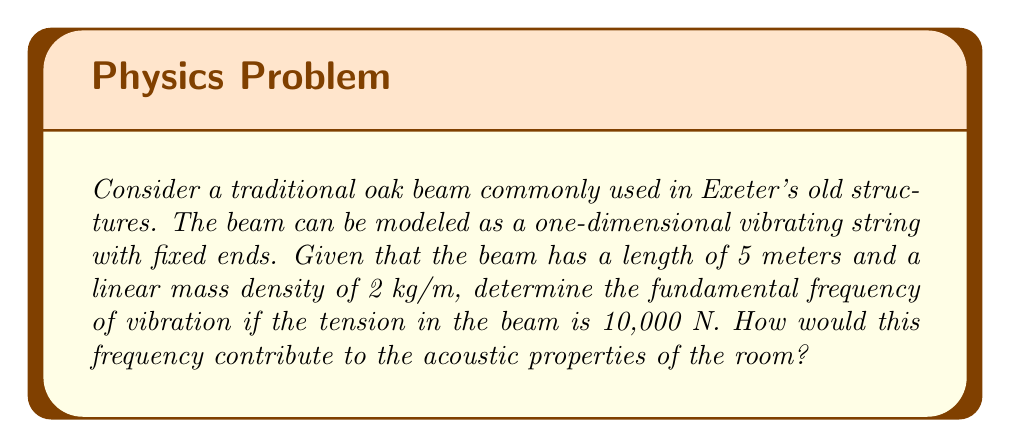What is the answer to this math problem? To solve this problem, we'll use the wave equation and spectral theory to determine the fundamental frequency of the oak beam.

1. The wave equation for a vibrating string is given by:

   $$\frac{\partial^2 u}{\partial t^2} = c^2 \frac{\partial^2 u}{\partial x^2}$$

   where $c$ is the wave speed.

2. The wave speed $c$ is related to the tension $T$ and linear mass density $\mu$ by:

   $$c = \sqrt{\frac{T}{\mu}}$$

3. Substituting the given values:
   $T = 10,000$ N
   $\mu = 2$ kg/m

   $$c = \sqrt{\frac{10,000}{2}} = \sqrt{5,000} \approx 70.71 \text{ m/s}$$

4. For a string with fixed ends, the eigenvalue problem is:

   $$-\frac{d^2\phi}{dx^2} = \lambda \phi$$
   
   with boundary conditions $\phi(0) = \phi(L) = 0$, where $L$ is the length of the string.

5. The eigenvalues are given by:

   $$\lambda_n = \left(\frac{n\pi}{L}\right)^2$$

   where $n = 1, 2, 3, ...$

6. The corresponding eigenfrequencies are:

   $$f_n = \frac{c}{2L} n$$

7. The fundamental frequency is the first eigenfrequency ($n = 1$):

   $$f_1 = \frac{c}{2L} = \frac{70.71}{2 \cdot 5} \approx 7.07 \text{ Hz}$$

8. This low-frequency vibration would contribute to the room's acoustic properties by:
   - Adding warmth to the overall sound
   - Potentially causing resonance with other low-frequency sounds
   - Affecting the room's reverberance, especially for bass frequencies
Answer: The fundamental frequency of the oak beam is approximately 7.07 Hz. This low-frequency vibration would contribute to the room's acoustic properties by adding warmth to the overall sound, potentially causing resonance with other low-frequency sounds, and affecting the room's reverberance, especially for bass frequencies. 